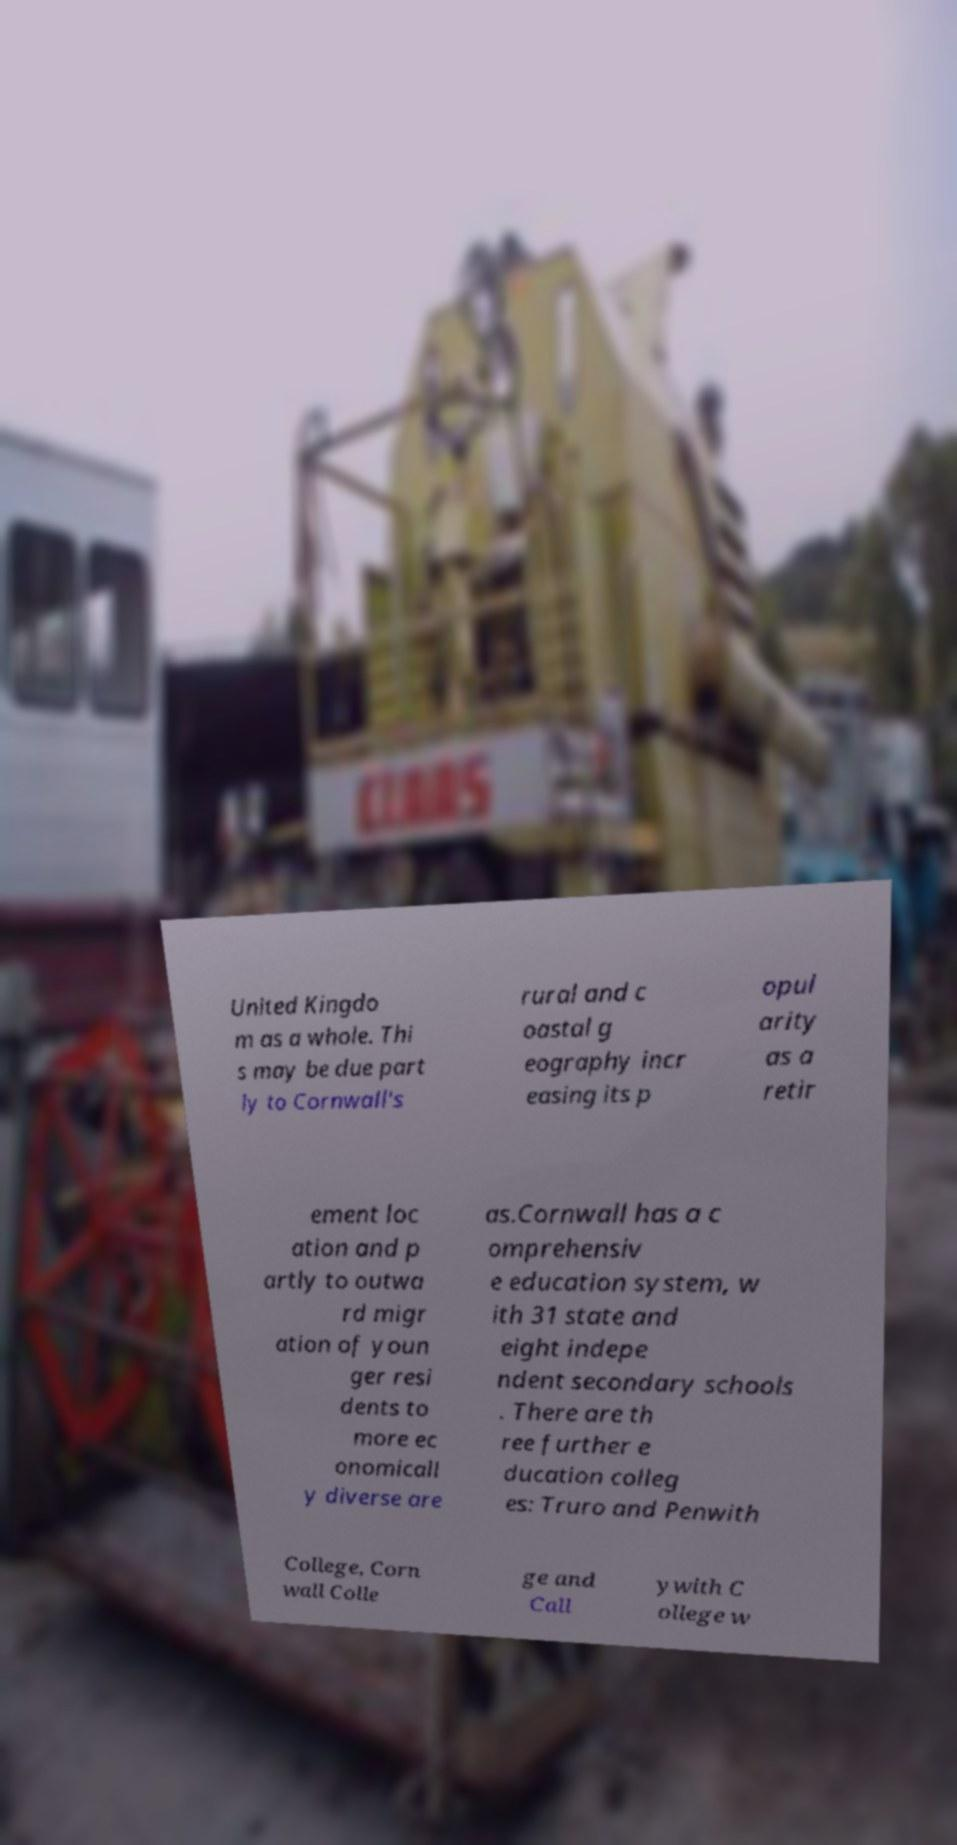Can you accurately transcribe the text from the provided image for me? United Kingdo m as a whole. Thi s may be due part ly to Cornwall's rural and c oastal g eography incr easing its p opul arity as a retir ement loc ation and p artly to outwa rd migr ation of youn ger resi dents to more ec onomicall y diverse are as.Cornwall has a c omprehensiv e education system, w ith 31 state and eight indepe ndent secondary schools . There are th ree further e ducation colleg es: Truro and Penwith College, Corn wall Colle ge and Call ywith C ollege w 